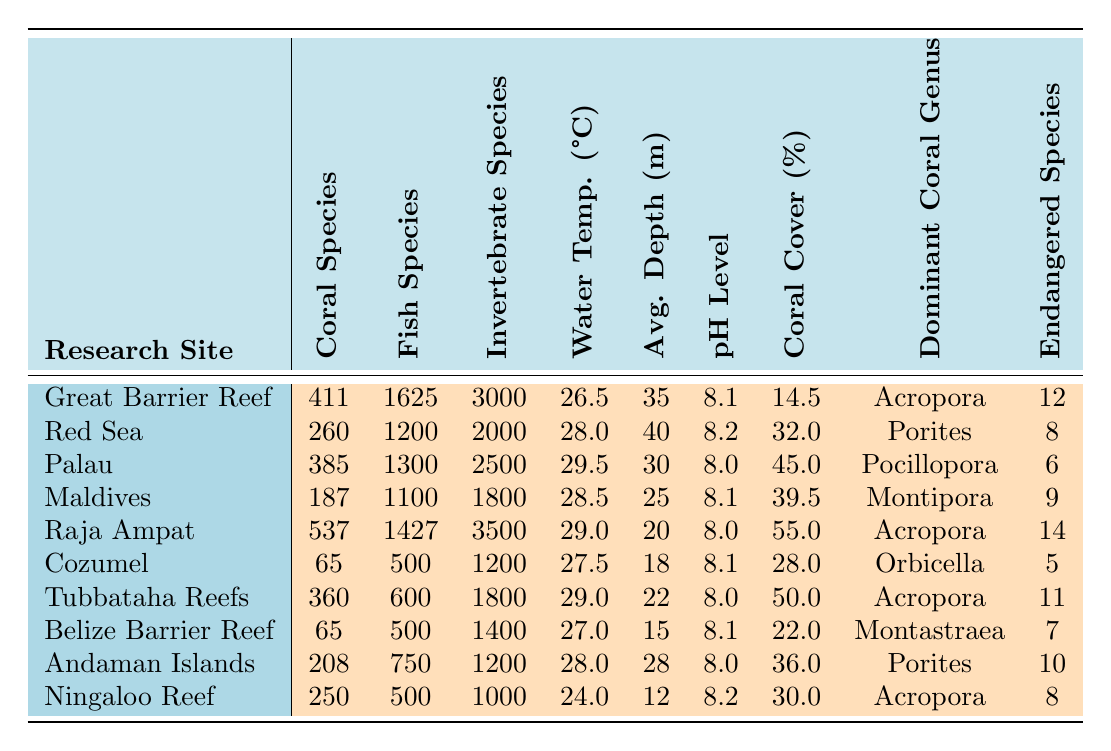What is the site with the highest coral species count? The table shows the coral species count for each site. By reviewing the values, I see that Raja Ampat has the highest count with 537 species.
Answer: Raja Ampat, Indonesia Which site has the lowest fish species count? Looking at the fish species count column, Cozumel and Belize Barrier Reef both have 500 species, which is the lowest among all sites.
Answer: Cozumel, Mexico and Belize Barrier Reef, Belize What is the average water temperature across all sites? Adding the water temperatures: (26.5 + 28.0 + 29.5 + 28.5 + 29.0 + 27.5 + 29.0 + 27.0 + 28.0 + 24.0) =  28.0. There are 10 sites, so the average is 280/10 = 28.0 °C.
Answer: 28.0 °C How many research sites have more than 3000 invertebrate species? Reviewing the invertebrate species column, only Great Barrier Reef (3000) and Raja Ampat (3500) have more than 3000 species; Tubbataha Reefs is the only other site close with 1800. So 2 sites qualify.
Answer: 2 Which site has the lowest coral cover percentage? The coral cover percentage for each site was analyzed, and Cozumel has the lowest at 28.0%.
Answer: Cozumel, Mexico Is the pH level of the Red Sea higher than 8.1? The table indicates the Red Sea has a pH level of 8.2, which is indeed higher than 8.1.
Answer: Yes Which two sites have the most endangered species? By checking the endangered species count, Raja Ampat (14) and Great Barrier Reef (12) have the highest counts.
Answer: Raja Ampat, Indonesia and Great Barrier Reef, Australia What is the total coral species count for all sites? Summing the coral species counts: (411 + 260 + 385 + 187 + 537 + 65 + 360 + 65 + 208 + 250) = 2373 species total across all sites.
Answer: 2373 species Which site has the highest average depth? Checking the average depth column, the Red Sea has the highest average depth of 40 meters.
Answer: Red Sea, Egypt How many sites have a coral cover percentage above 30%? Reviewing the coral cover percentages, sites like Red Sea (32.0%), Palau (45.0%), Raja Ampat (55.0%), Tubbataha Reefs (50.0%), and Maldives (39.5%) are above 30%. That makes 5 sites in total.
Answer: 5 